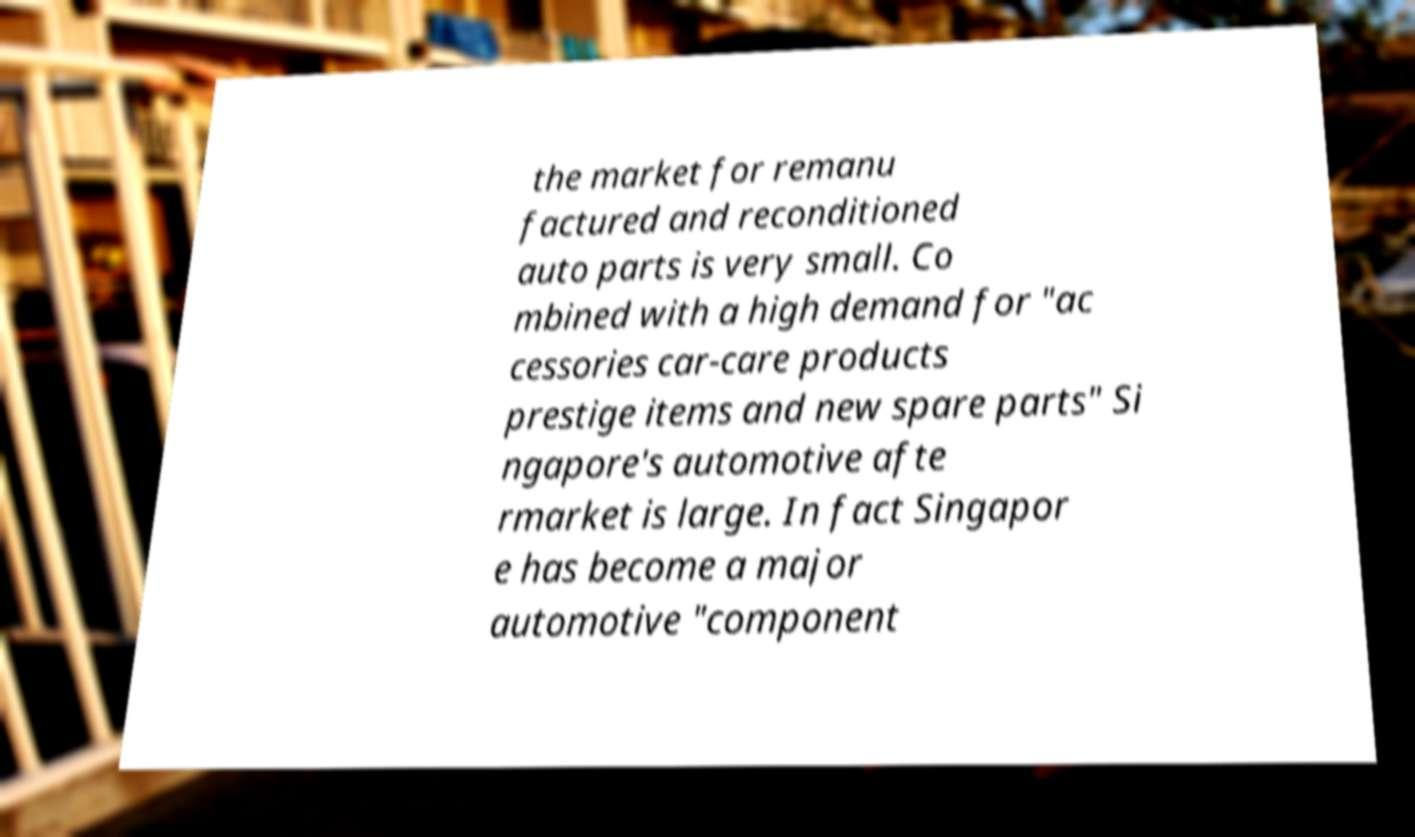I need the written content from this picture converted into text. Can you do that? the market for remanu factured and reconditioned auto parts is very small. Co mbined with a high demand for "ac cessories car-care products prestige items and new spare parts" Si ngapore's automotive afte rmarket is large. In fact Singapor e has become a major automotive "component 